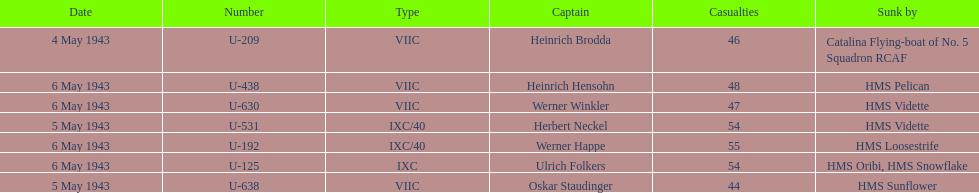Aside from oskar staudinger what was the name of the other captain of the u-boat loast on may 5? Herbert Neckel. 